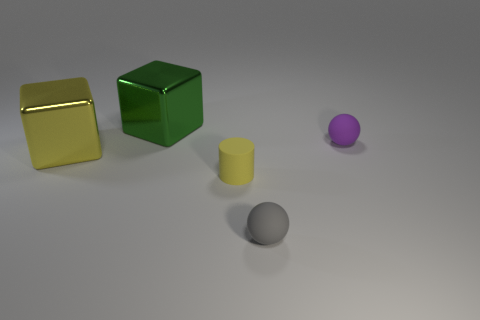There is a yellow object that is on the right side of the metallic object that is in front of the purple matte thing; what number of purple spheres are in front of it?
Give a very brief answer. 0. Are there fewer purple balls that are on the left side of the green thing than balls that are on the left side of the small yellow rubber object?
Make the answer very short. No. How many other things are the same material as the small purple ball?
Your response must be concise. 2. What material is the other block that is the same size as the green cube?
Your answer should be very brief. Metal. How many green objects are either cylinders or shiny objects?
Make the answer very short. 1. What is the color of the thing that is both behind the cylinder and right of the big green metal cube?
Offer a very short reply. Purple. Is the ball behind the tiny yellow rubber object made of the same material as the large object on the right side of the yellow cube?
Your answer should be compact. No. Are there more tiny cylinders to the right of the tiny purple rubber thing than big green metallic cubes in front of the rubber cylinder?
Offer a terse response. No. The gray rubber object that is the same size as the matte cylinder is what shape?
Make the answer very short. Sphere. How many things are big green things or small things to the right of the small gray rubber object?
Make the answer very short. 2. 